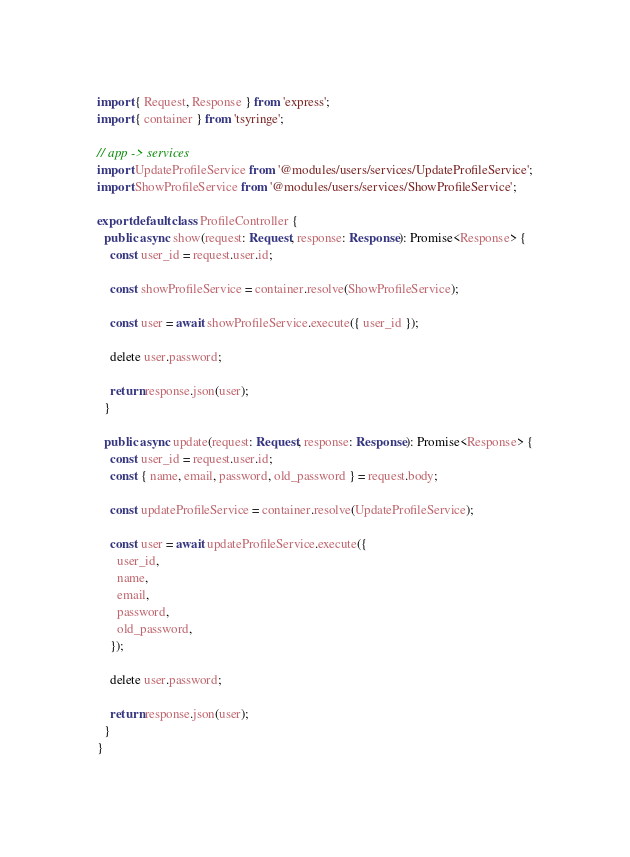Convert code to text. <code><loc_0><loc_0><loc_500><loc_500><_TypeScript_>import { Request, Response } from 'express';
import { container } from 'tsyringe';

// app -> services
import UpdateProfileService from '@modules/users/services/UpdateProfileService';
import ShowProfileService from '@modules/users/services/ShowProfileService';

export default class ProfileController {
  public async show(request: Request, response: Response): Promise<Response> {
    const user_id = request.user.id;

    const showProfileService = container.resolve(ShowProfileService);

    const user = await showProfileService.execute({ user_id });

    delete user.password;

    return response.json(user);
  }

  public async update(request: Request, response: Response): Promise<Response> {
    const user_id = request.user.id;
    const { name, email, password, old_password } = request.body;

    const updateProfileService = container.resolve(UpdateProfileService);

    const user = await updateProfileService.execute({
      user_id,
      name,
      email,
      password,
      old_password,
    });

    delete user.password;

    return response.json(user);
  }
}
</code> 